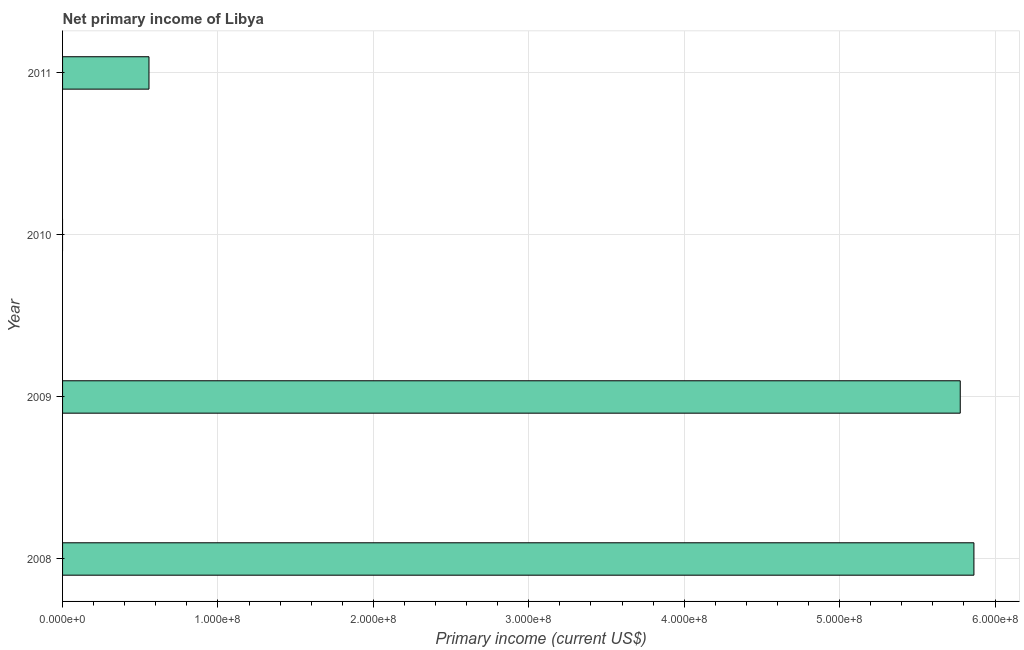Does the graph contain grids?
Give a very brief answer. Yes. What is the title of the graph?
Your answer should be compact. Net primary income of Libya. What is the label or title of the X-axis?
Your answer should be compact. Primary income (current US$). What is the label or title of the Y-axis?
Make the answer very short. Year. What is the amount of primary income in 2008?
Provide a succinct answer. 5.86e+08. Across all years, what is the maximum amount of primary income?
Offer a terse response. 5.86e+08. What is the sum of the amount of primary income?
Give a very brief answer. 1.22e+09. What is the difference between the amount of primary income in 2008 and 2011?
Your response must be concise. 5.31e+08. What is the average amount of primary income per year?
Offer a terse response. 3.05e+08. What is the median amount of primary income?
Provide a short and direct response. 3.17e+08. In how many years, is the amount of primary income greater than 220000000 US$?
Give a very brief answer. 2. What is the ratio of the amount of primary income in 2008 to that in 2011?
Your answer should be very brief. 10.55. Is the amount of primary income in 2008 less than that in 2009?
Your answer should be compact. No. What is the difference between the highest and the second highest amount of primary income?
Make the answer very short. 8.80e+06. Is the sum of the amount of primary income in 2008 and 2011 greater than the maximum amount of primary income across all years?
Provide a short and direct response. Yes. What is the difference between the highest and the lowest amount of primary income?
Offer a very short reply. 5.86e+08. In how many years, is the amount of primary income greater than the average amount of primary income taken over all years?
Give a very brief answer. 2. What is the Primary income (current US$) of 2008?
Offer a terse response. 5.86e+08. What is the Primary income (current US$) in 2009?
Ensure brevity in your answer.  5.78e+08. What is the Primary income (current US$) of 2010?
Your answer should be very brief. 0. What is the Primary income (current US$) of 2011?
Ensure brevity in your answer.  5.56e+07. What is the difference between the Primary income (current US$) in 2008 and 2009?
Keep it short and to the point. 8.80e+06. What is the difference between the Primary income (current US$) in 2008 and 2011?
Make the answer very short. 5.31e+08. What is the difference between the Primary income (current US$) in 2009 and 2011?
Provide a short and direct response. 5.22e+08. What is the ratio of the Primary income (current US$) in 2008 to that in 2011?
Offer a very short reply. 10.55. What is the ratio of the Primary income (current US$) in 2009 to that in 2011?
Your response must be concise. 10.39. 